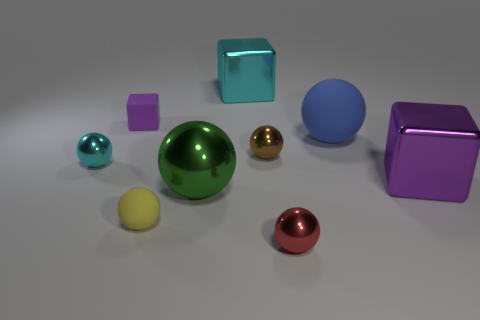Subtract all cyan balls. How many balls are left? 5 Subtract 2 spheres. How many spheres are left? 4 Subtract all small red balls. How many balls are left? 5 Subtract all red spheres. Subtract all purple cylinders. How many spheres are left? 5 Add 1 large blue spheres. How many objects exist? 10 Subtract all blocks. How many objects are left? 6 Add 5 small rubber objects. How many small rubber objects are left? 7 Add 3 brown spheres. How many brown spheres exist? 4 Subtract 0 yellow blocks. How many objects are left? 9 Subtract all yellow rubber spheres. Subtract all tiny yellow rubber balls. How many objects are left? 7 